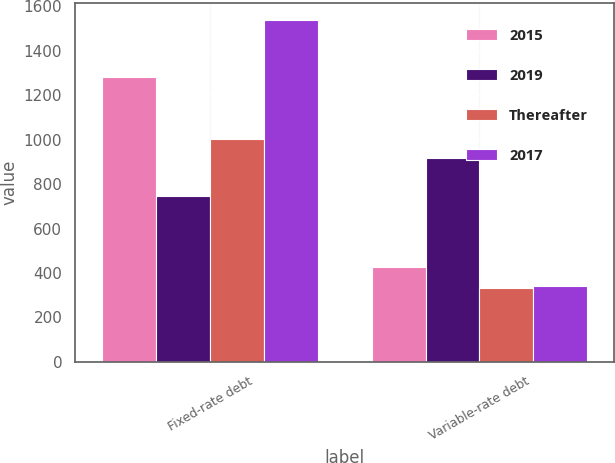Convert chart. <chart><loc_0><loc_0><loc_500><loc_500><stacked_bar_chart><ecel><fcel>Fixed-rate debt<fcel>Variable-rate debt<nl><fcel>2015<fcel>1281<fcel>427<nl><fcel>2019<fcel>745<fcel>917<nl><fcel>Thereafter<fcel>1005<fcel>333<nl><fcel>2017<fcel>1539<fcel>340<nl></chart> 